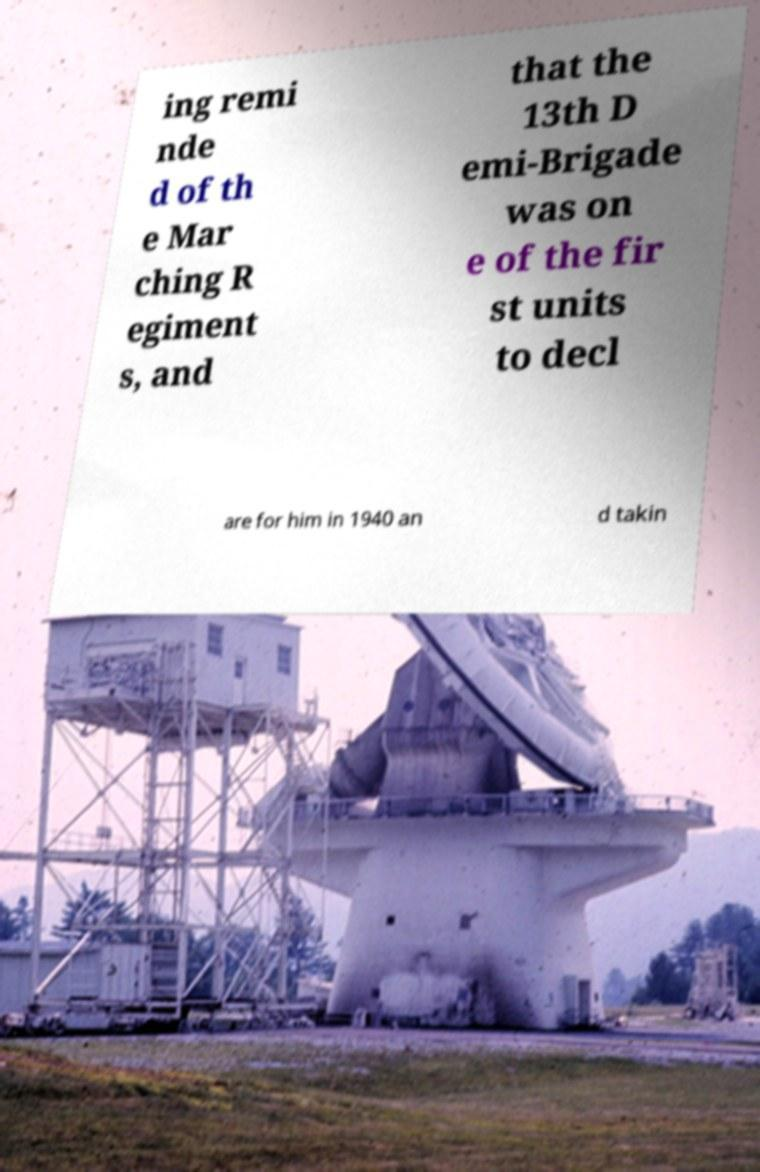For documentation purposes, I need the text within this image transcribed. Could you provide that? ing remi nde d of th e Mar ching R egiment s, and that the 13th D emi-Brigade was on e of the fir st units to decl are for him in 1940 an d takin 